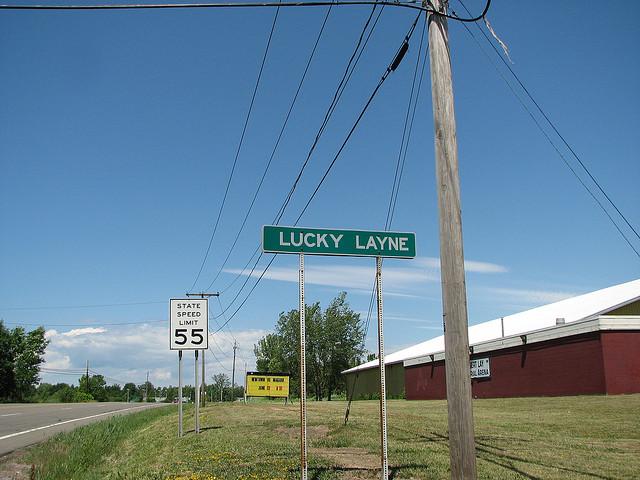Is this an urban or suburban environment?
Quick response, please. Suburban. What street is this?
Write a very short answer. Lucky layne. What is the speed limit?
Give a very brief answer. 55. 